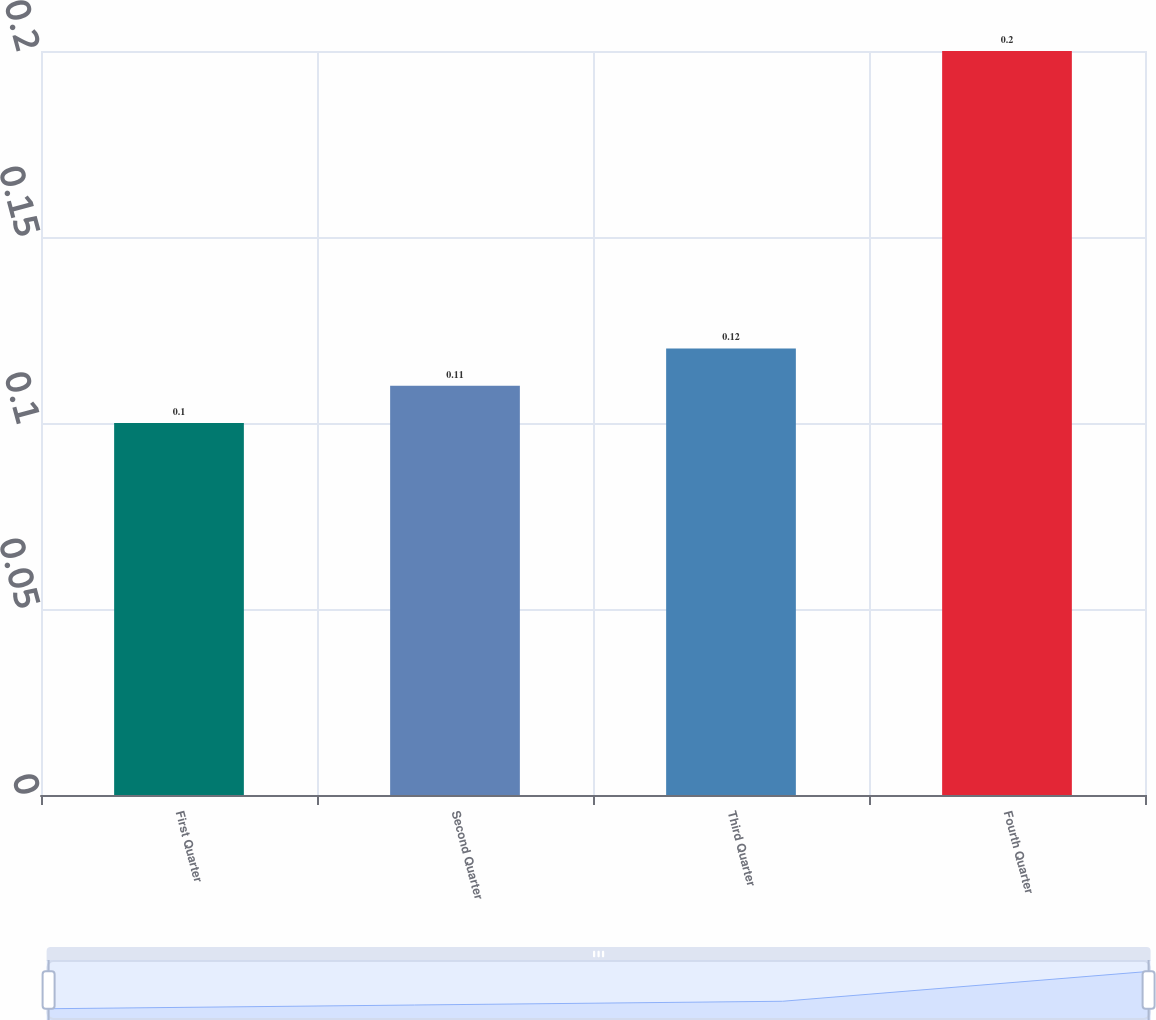<chart> <loc_0><loc_0><loc_500><loc_500><bar_chart><fcel>First Quarter<fcel>Second Quarter<fcel>Third Quarter<fcel>Fourth Quarter<nl><fcel>0.1<fcel>0.11<fcel>0.12<fcel>0.2<nl></chart> 